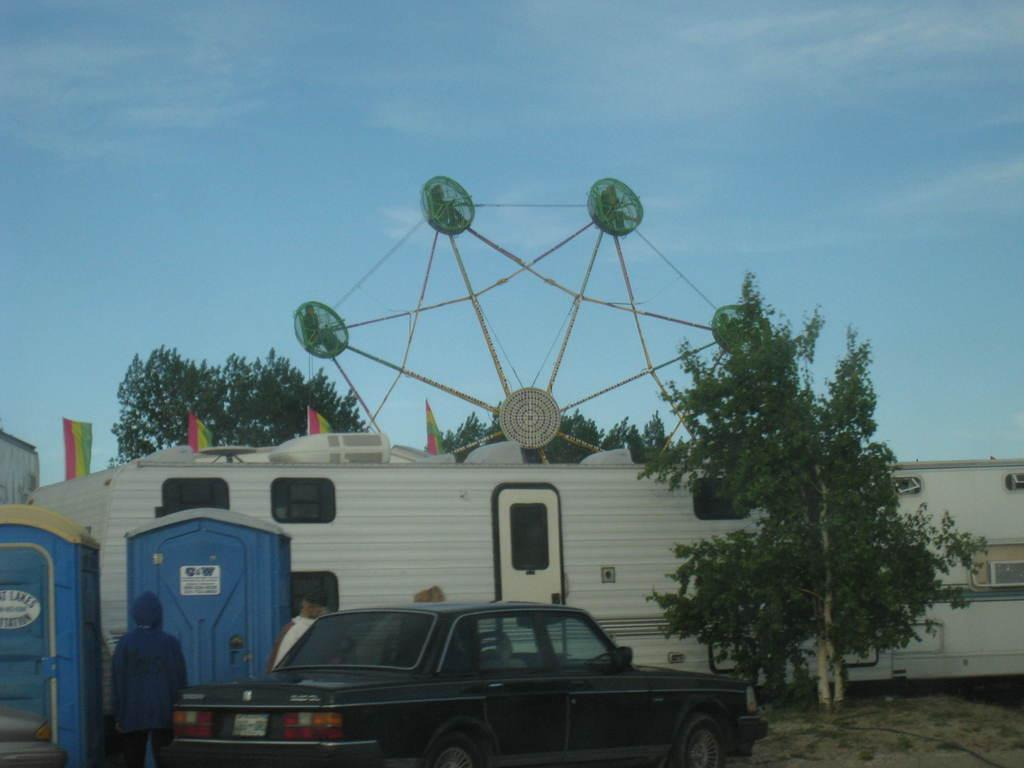What is the main subject of the image? There is a car in the image. What else can be seen in the image besides the car? There are people standing on the ground, trees, containers, and booths in the image. What is visible in the background of the image? The sky is visible in the background of the image, and clouds are present in the sky. What type of record is being played at the party in the image? There is no party or record present in the image; it features a car, people, trees, containers, and booths. Can you see the tongue of the person standing next to the car in the image? There is no indication of a person's tongue in the image; it only shows a car, people, trees, containers, and booths. 